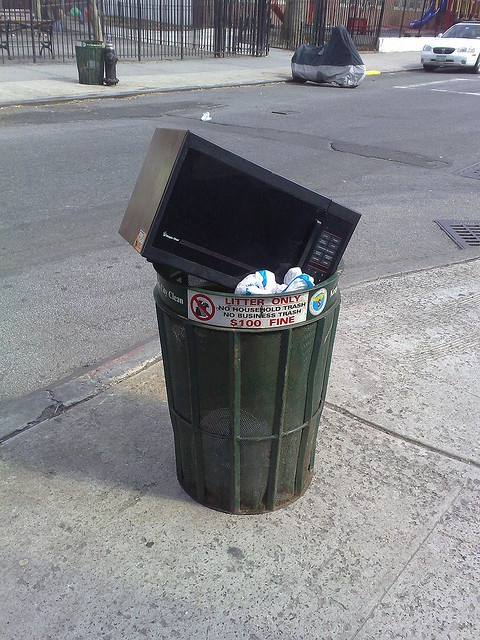Describe the objects in this image and their specific colors. I can see microwave in gray, black, and darkgray tones, motorcycle in gray and black tones, car in gray, white, and darkgray tones, and fire hydrant in gray, black, and darkgray tones in this image. 